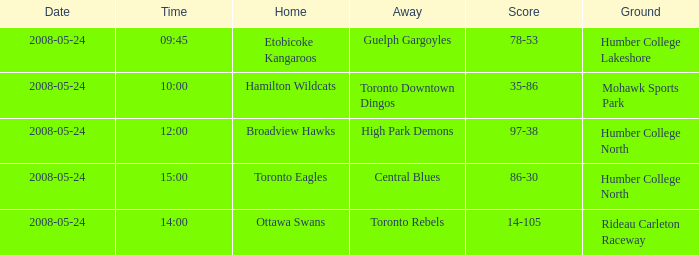Which team was the home side in the match at 14:00? Ottawa Swans. 